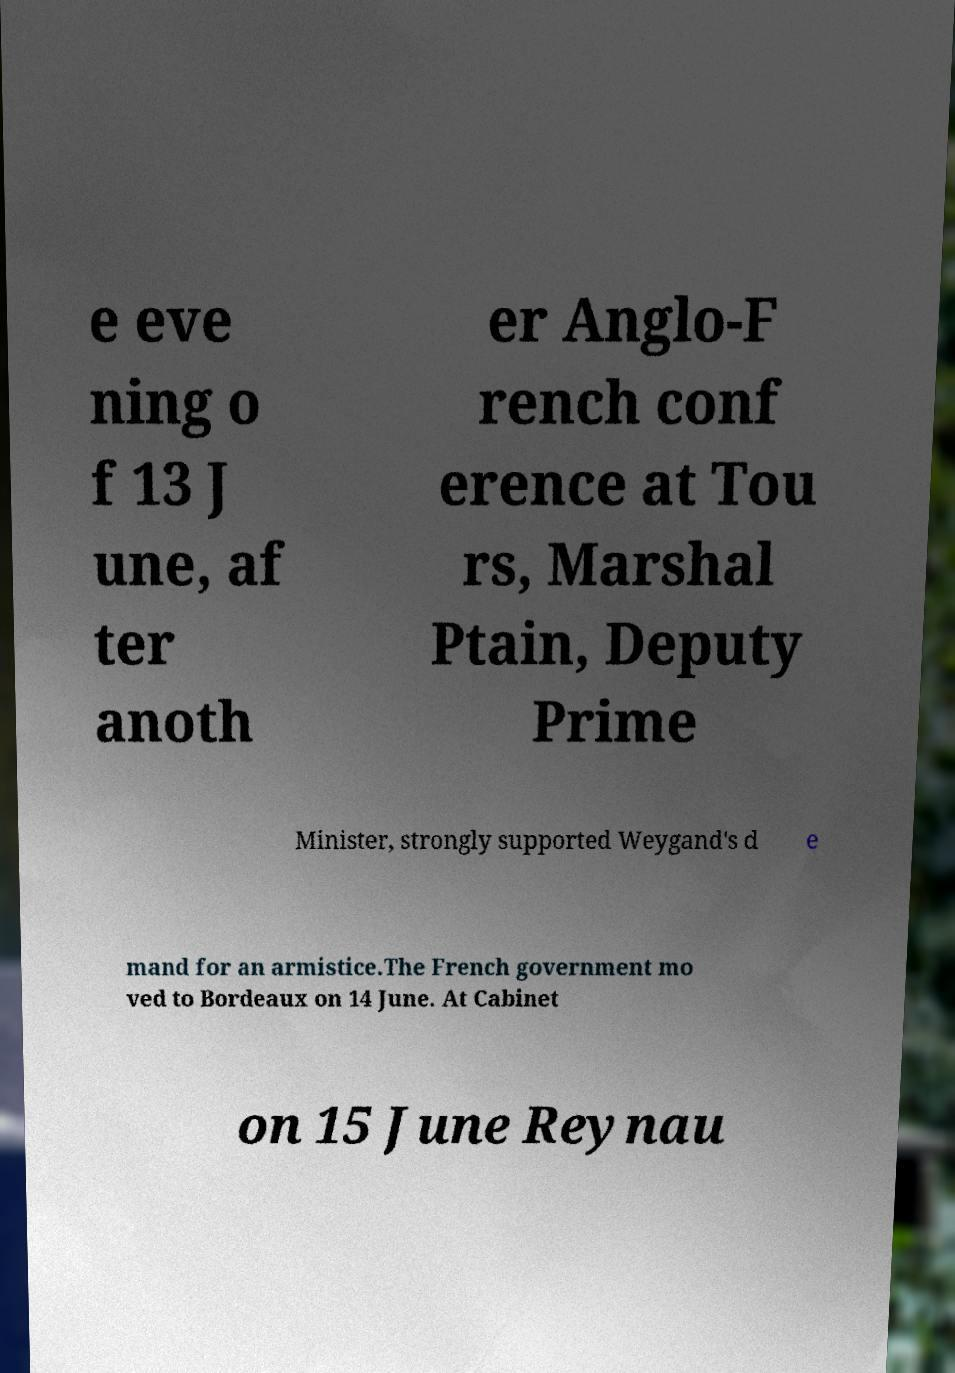Could you extract and type out the text from this image? e eve ning o f 13 J une, af ter anoth er Anglo-F rench conf erence at Tou rs, Marshal Ptain, Deputy Prime Minister, strongly supported Weygand's d e mand for an armistice.The French government mo ved to Bordeaux on 14 June. At Cabinet on 15 June Reynau 